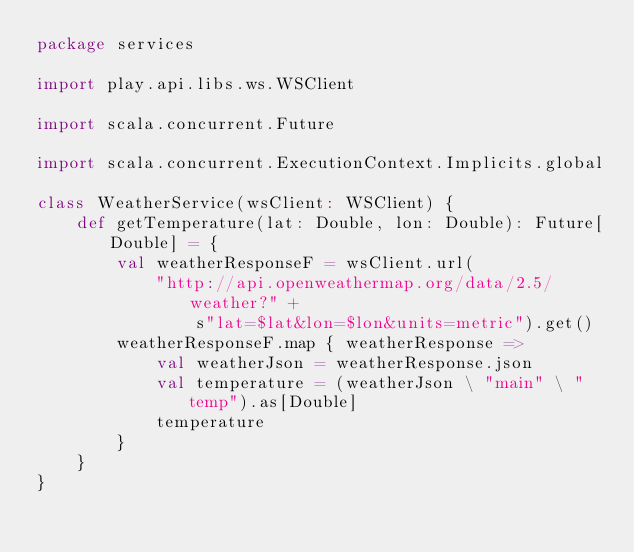Convert code to text. <code><loc_0><loc_0><loc_500><loc_500><_Scala_>package services

import play.api.libs.ws.WSClient

import scala.concurrent.Future

import scala.concurrent.ExecutionContext.Implicits.global

class WeatherService(wsClient: WSClient) {
    def getTemperature(lat: Double, lon: Double): Future[Double] = {
        val weatherResponseF = wsClient.url(
            "http://api.openweathermap.org/data/2.5/weather?" +
                s"lat=$lat&lon=$lon&units=metric").get()
        weatherResponseF.map { weatherResponse =>
            val weatherJson = weatherResponse.json
            val temperature = (weatherJson \ "main" \ "temp").as[Double]
            temperature
        }
    }
}
</code> 